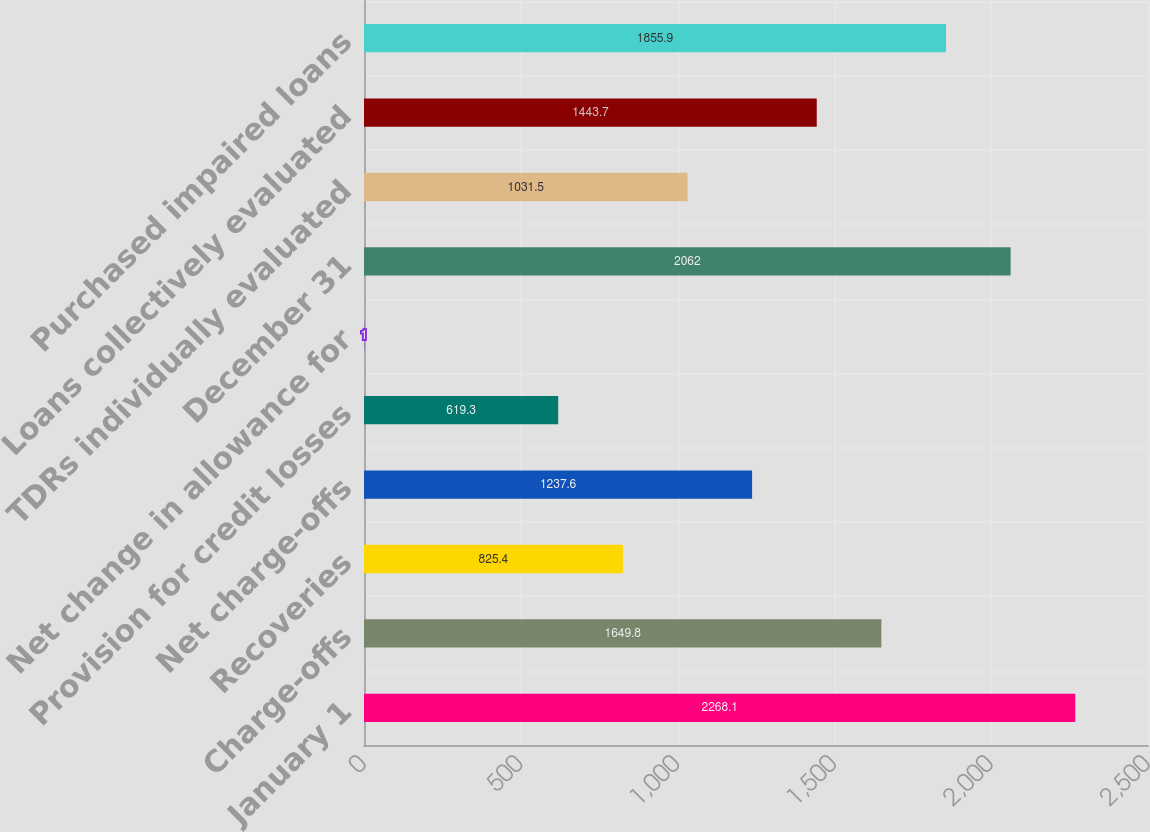Convert chart. <chart><loc_0><loc_0><loc_500><loc_500><bar_chart><fcel>January 1<fcel>Charge-offs<fcel>Recoveries<fcel>Net charge-offs<fcel>Provision for credit losses<fcel>Net change in allowance for<fcel>December 31<fcel>TDRs individually evaluated<fcel>Loans collectively evaluated<fcel>Purchased impaired loans<nl><fcel>2268.1<fcel>1649.8<fcel>825.4<fcel>1237.6<fcel>619.3<fcel>1<fcel>2062<fcel>1031.5<fcel>1443.7<fcel>1855.9<nl></chart> 